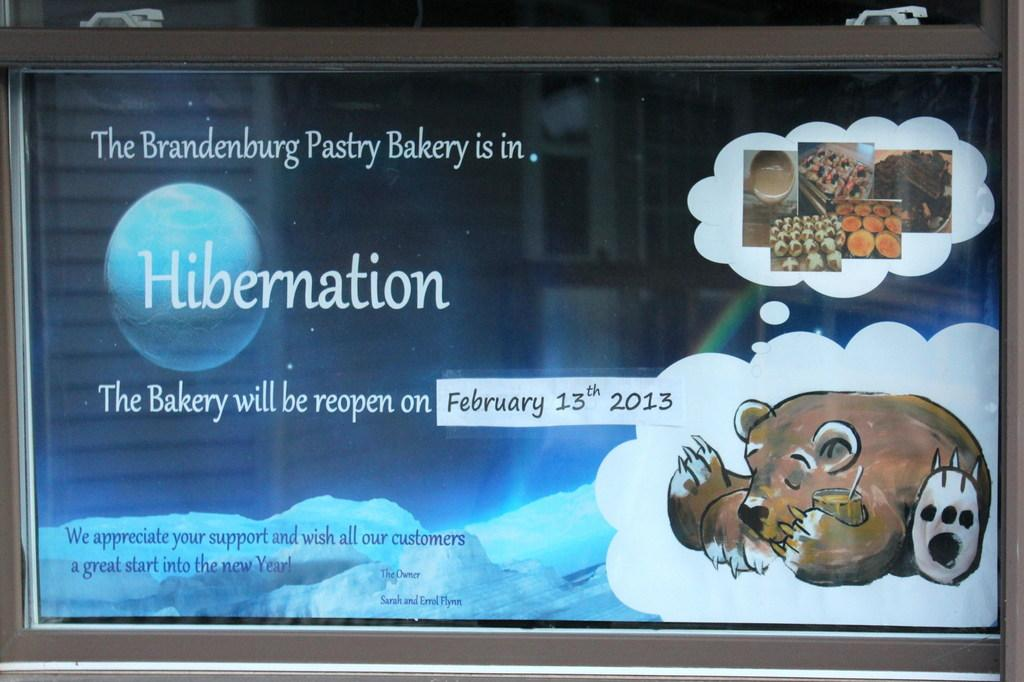What is the main object in the image? There is a screen in the image. What can be seen on the screen? The screen displays text, images of an animal, and images of food items. Where is the wrench located in the image? There is no wrench present in the image. What type of house is shown in the image? There is no house shown in the image; it features a screen displaying text and images. 